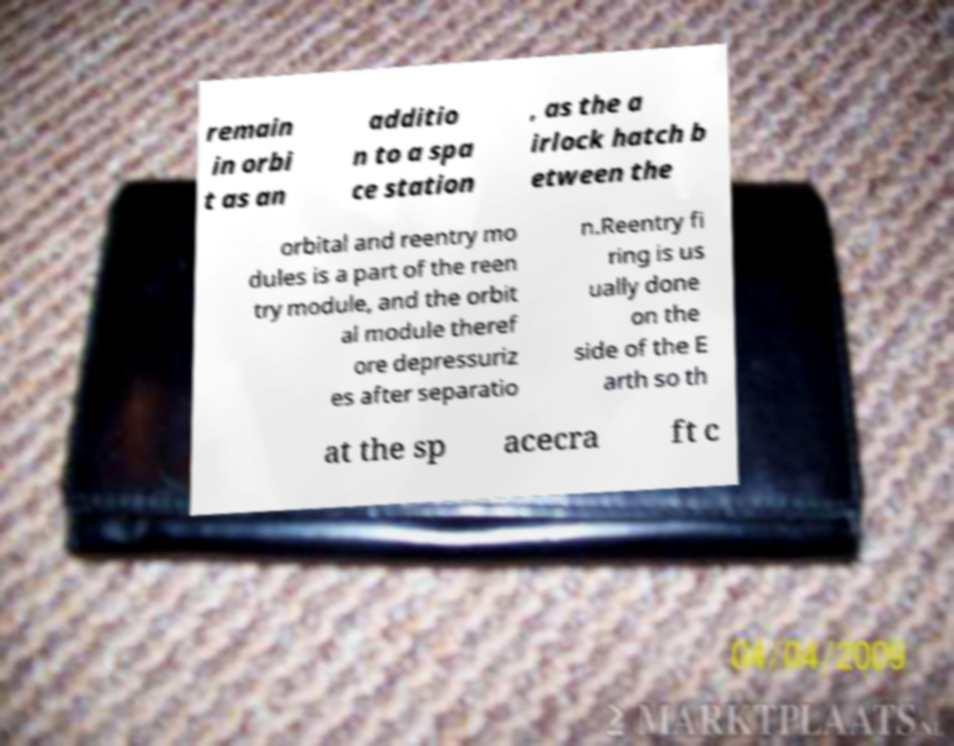What messages or text are displayed in this image? I need them in a readable, typed format. remain in orbi t as an additio n to a spa ce station , as the a irlock hatch b etween the orbital and reentry mo dules is a part of the reen try module, and the orbit al module theref ore depressuriz es after separatio n.Reentry fi ring is us ually done on the side of the E arth so th at the sp acecra ft c 